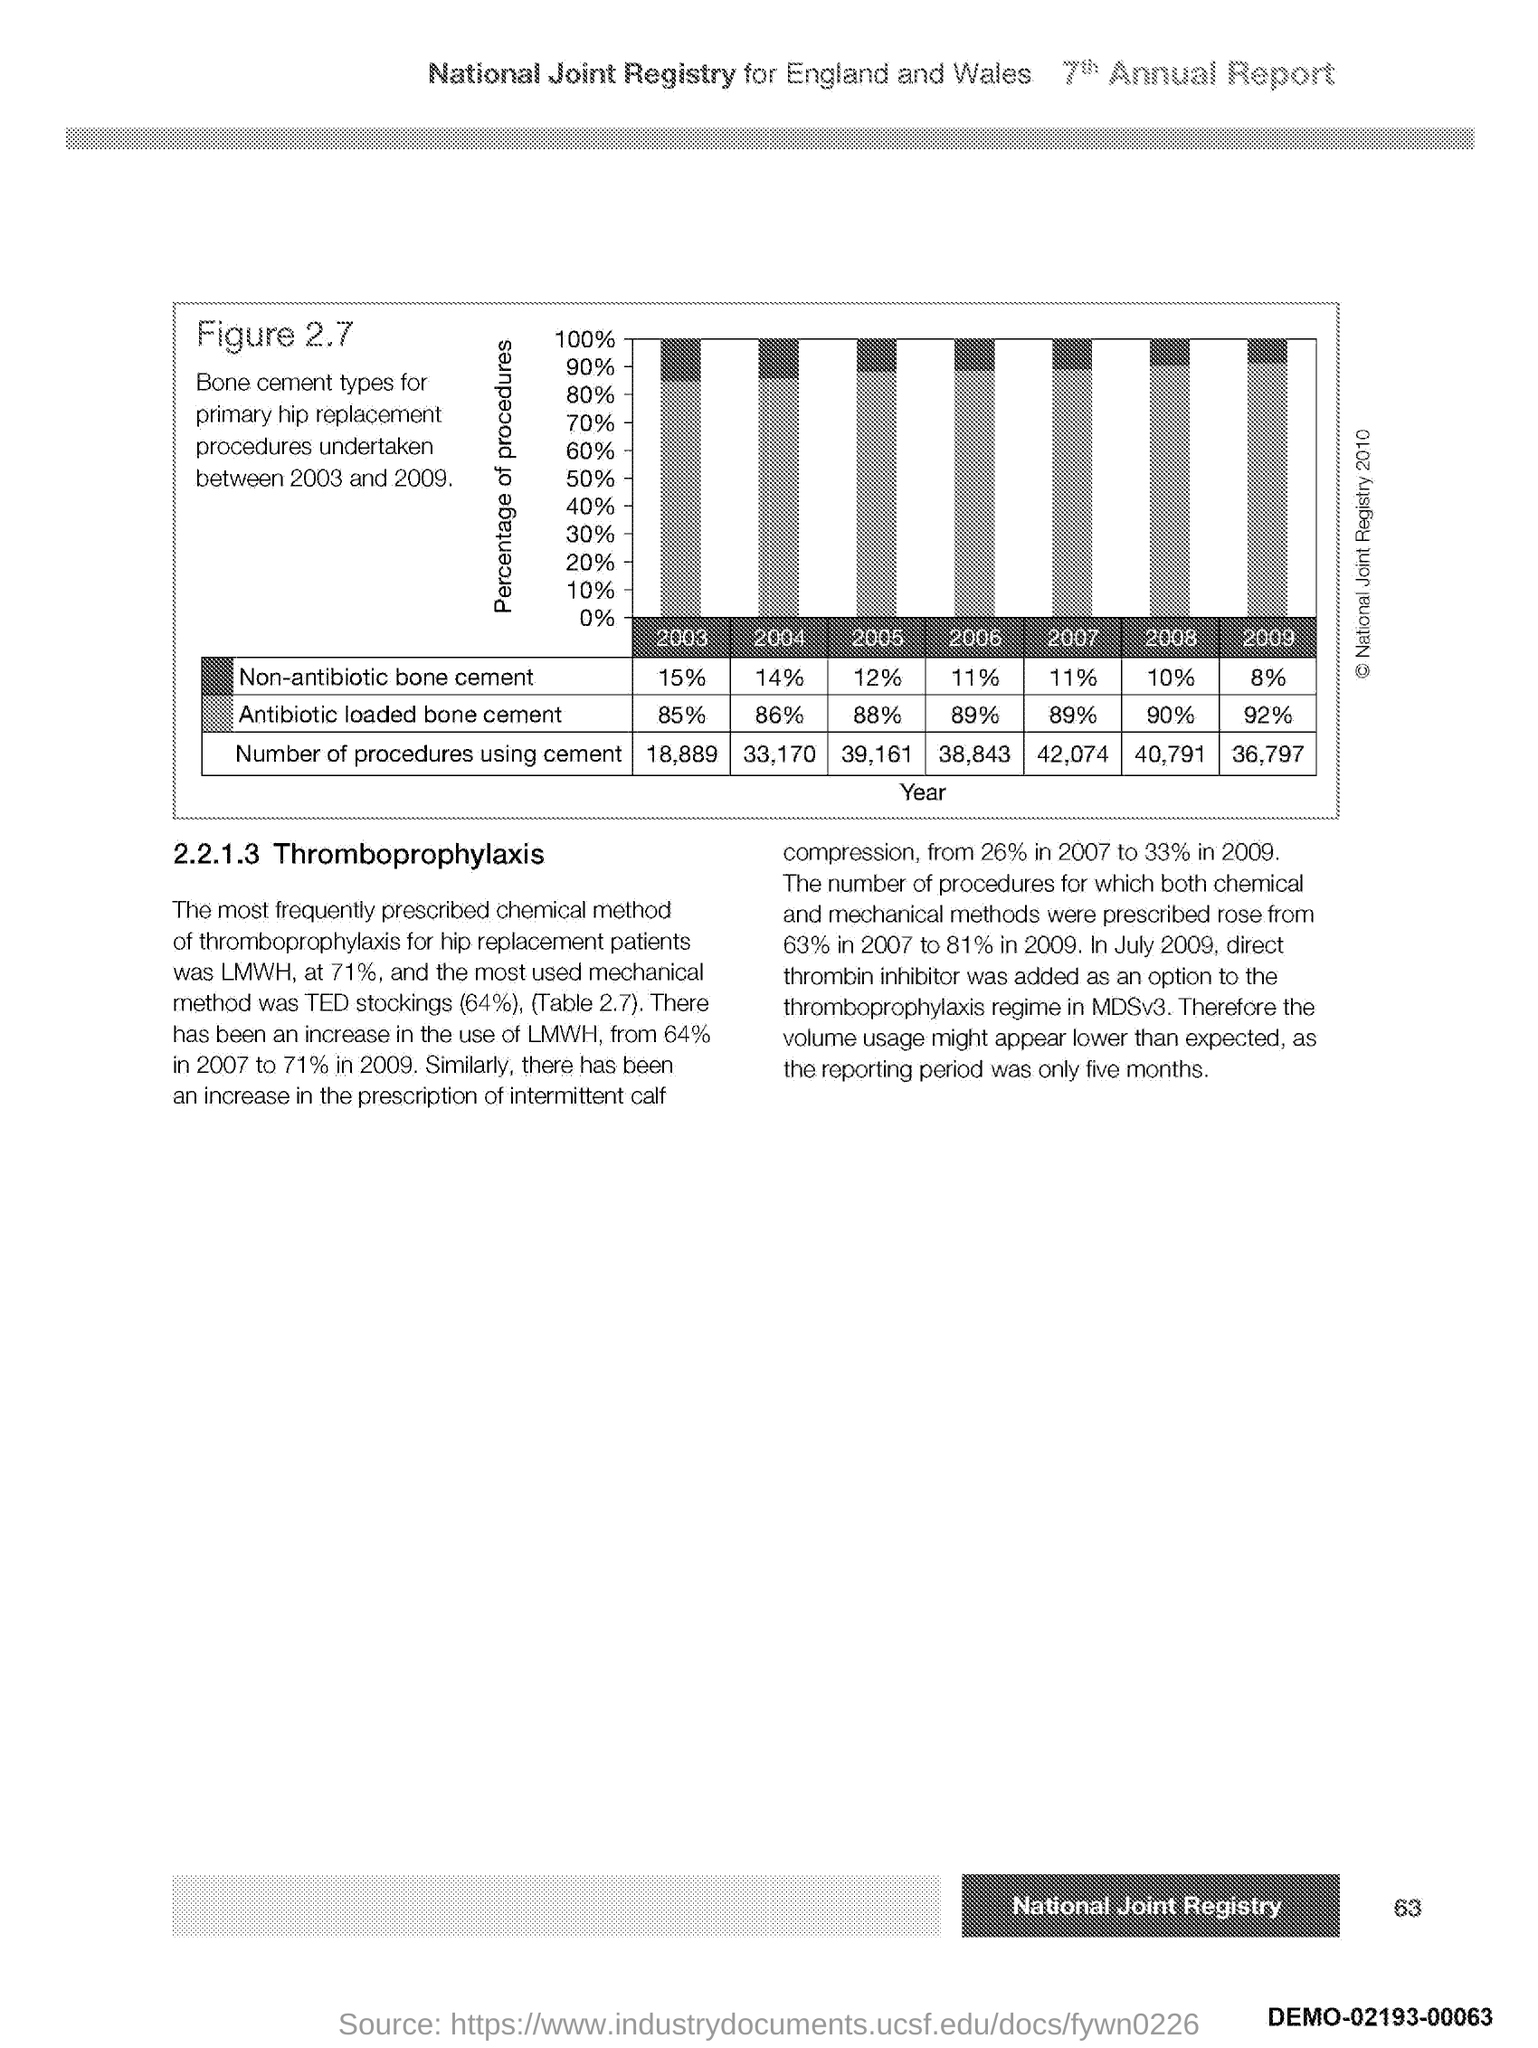Indicate a few pertinent items in this graphic. What is depicted in Figure 2.7? Bone cement types. The title of this page mentions two countries: England and Wales. These countries are England and Wales. According to Figure 2.7, in the year 2008, non-antibiotic bone cement was used at a rate of approximately 10% of the total bone cement used. According to Figure 2.7, there were 39,161 procedures that involved the use of cement in the year 2005. According to Figure 2.7, in the year 2007, approximately 89% of the antibiotic-loaded bone cement was used. 